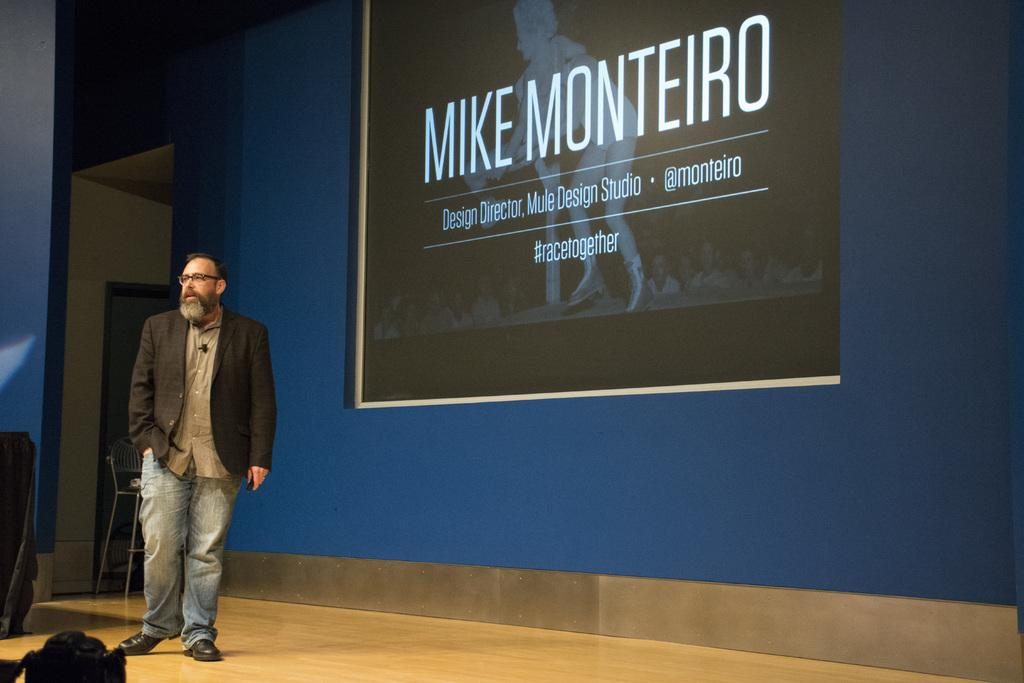What can be seen in the image? There is a person in the image. Can you describe the person's clothing? The person is wearing a black coat. What accessory is the person wearing? The person is wearing spectacles. Where is the person standing? The person is standing on the floor. What objects can be seen in the background of the image? There is a chair and a screen on the wall in the background of the image. How is the chair positioned in the image? The chair is placed on the ground. What type of shoe is the person wearing in the image? The provided facts do not mention any shoes, so we cannot determine the type of shoe the person is wearing. 